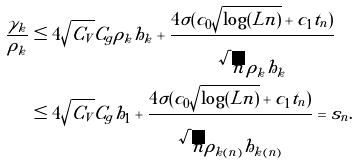<formula> <loc_0><loc_0><loc_500><loc_500>\frac { \gamma _ { k } } { \rho _ { k } } & \leq 4 \sqrt { C _ { V } } C _ { g } \rho _ { k } h _ { k } + \frac { 4 \sigma ( c _ { 0 } \sqrt { \log ( L n ) } + c _ { 1 } t _ { n } ) } { \sqrt { n } \, \rho _ { k } h _ { k } } \\ & \leq 4 \sqrt { C _ { V } } C _ { g } h _ { 1 } + \frac { 4 \sigma ( c _ { 0 } \sqrt { \log ( L n ) } + c _ { 1 } t _ { n } ) } { \sqrt { n } \rho _ { k ( n ) } h _ { k ( n ) } } = s _ { n } .</formula> 